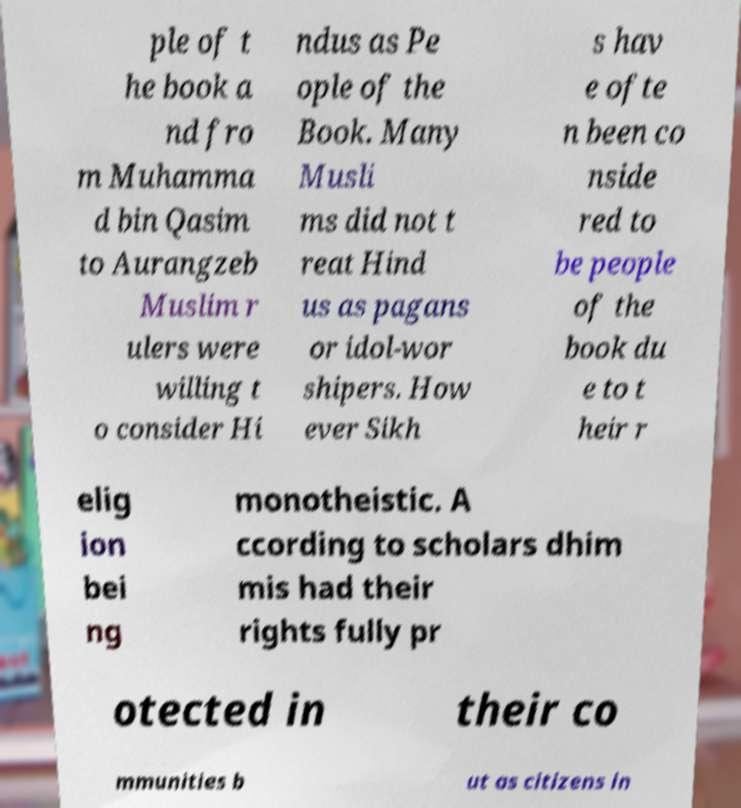For documentation purposes, I need the text within this image transcribed. Could you provide that? ple of t he book a nd fro m Muhamma d bin Qasim to Aurangzeb Muslim r ulers were willing t o consider Hi ndus as Pe ople of the Book. Many Musli ms did not t reat Hind us as pagans or idol-wor shipers. How ever Sikh s hav e ofte n been co nside red to be people of the book du e to t heir r elig ion bei ng monotheistic. A ccording to scholars dhim mis had their rights fully pr otected in their co mmunities b ut as citizens in 